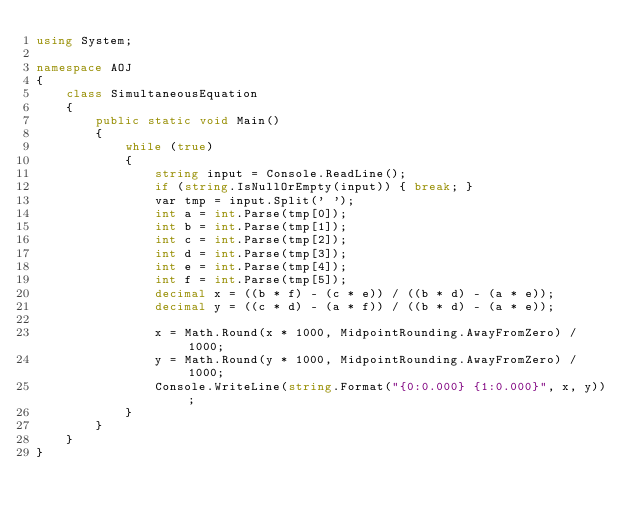Convert code to text. <code><loc_0><loc_0><loc_500><loc_500><_C#_>using System;

namespace AOJ
{
    class SimultaneousEquation
    {
        public static void Main()
        {
            while (true)
            {
                string input = Console.ReadLine();
                if (string.IsNullOrEmpty(input)) { break; }
                var tmp = input.Split(' ');
                int a = int.Parse(tmp[0]);
                int b = int.Parse(tmp[1]);
                int c = int.Parse(tmp[2]);
                int d = int.Parse(tmp[3]);
                int e = int.Parse(tmp[4]);
                int f = int.Parse(tmp[5]);
                decimal x = ((b * f) - (c * e)) / ((b * d) - (a * e));
                decimal y = ((c * d) - (a * f)) / ((b * d) - (a * e));

                x = Math.Round(x * 1000, MidpointRounding.AwayFromZero) / 1000;
                y = Math.Round(y * 1000, MidpointRounding.AwayFromZero) / 1000;
                Console.WriteLine(string.Format("{0:0.000} {1:0.000}", x, y));
            }
        }
    }
}</code> 